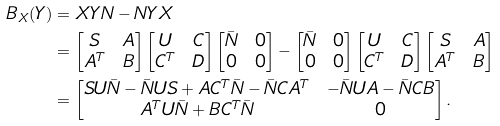<formula> <loc_0><loc_0><loc_500><loc_500>B _ { X } ( Y ) & = X Y N - N Y X \\ & = \begin{bmatrix} S & A \\ A ^ { T } & B \end{bmatrix} \begin{bmatrix} U & C \\ C ^ { T } & D \end{bmatrix} \begin{bmatrix} \bar { N } & 0 \\ 0 & 0 \end{bmatrix} - \begin{bmatrix} \bar { N } & 0 \\ 0 & 0 \end{bmatrix} \begin{bmatrix} U & C \\ C ^ { T } & D \end{bmatrix} \begin{bmatrix} S & A \\ A ^ { T } & B \end{bmatrix} \\ & = \begin{bmatrix} S U \bar { N } - \bar { N } U S + A C ^ { T } \bar { N } - \bar { N } C A ^ { T } & - \bar { N } U A - \bar { N } C B \\ A ^ { T } U \bar { N } + B C ^ { T } \bar { N } & 0 \end{bmatrix} .</formula> 